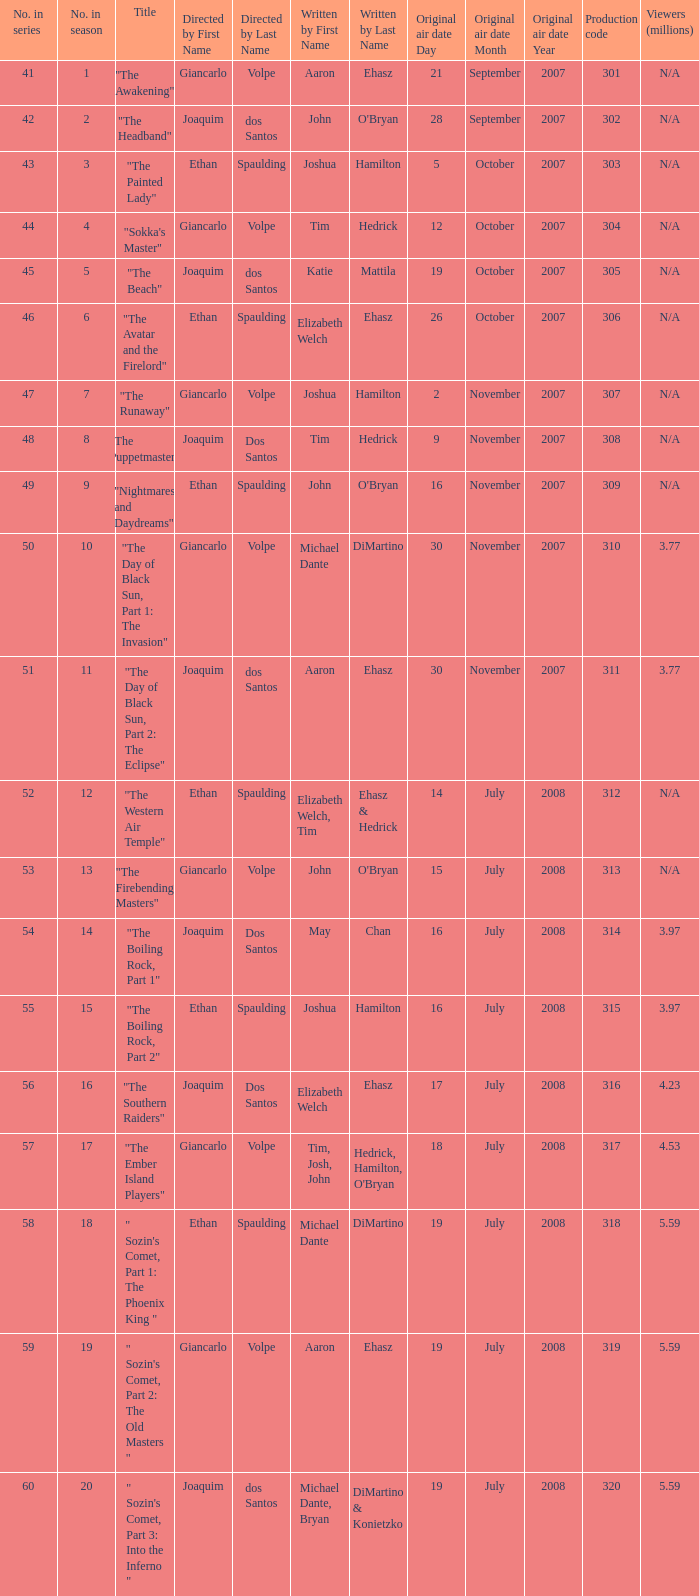Could you help me parse every detail presented in this table? {'header': ['No. in series', 'No. in season', 'Title', 'Directed by First Name', 'Directed by Last Name', 'Written by First Name', 'Written by Last Name', 'Original air date Day', 'Original air date Month', 'Original air date Year', 'Production code', 'Viewers (millions)'], 'rows': [['41', '1', '"The Awakening"', 'Giancarlo', 'Volpe', 'Aaron', 'Ehasz', '21', 'September', '2007', '301', 'N/A'], ['42', '2', '"The Headband"', 'Joaquim', 'dos Santos', 'John', "O'Bryan", '28', 'September', '2007', '302', 'N/A'], ['43', '3', '"The Painted Lady"', 'Ethan', 'Spaulding', 'Joshua', 'Hamilton', '5', 'October', '2007', '303', 'N/A'], ['44', '4', '"Sokka\'s Master"', 'Giancarlo', 'Volpe', 'Tim', 'Hedrick', '12', 'October', '2007', '304', 'N/A'], ['45', '5', '"The Beach"', 'Joaquim', 'dos Santos', 'Katie', 'Mattila', '19', 'October', '2007', '305', 'N/A'], ['46', '6', '"The Avatar and the Firelord"', 'Ethan', 'Spaulding', 'Elizabeth Welch', 'Ehasz', '26', 'October', '2007', '306', 'N/A'], ['47', '7', '"The Runaway"', 'Giancarlo', 'Volpe', 'Joshua', 'Hamilton', '2', 'November', '2007', '307', 'N/A'], ['48', '8', '"The Puppetmaster"', 'Joaquim', 'Dos Santos', 'Tim', 'Hedrick', '9', 'November', '2007', '308', 'N/A'], ['49', '9', '"Nightmares and Daydreams"', 'Ethan', 'Spaulding', 'John', "O'Bryan", '16', 'November', '2007', '309', 'N/A'], ['50', '10', '"The Day of Black Sun, Part 1: The Invasion"', 'Giancarlo', 'Volpe', 'Michael Dante', 'DiMartino', '30', 'November', '2007', '310', '3.77'], ['51', '11', '"The Day of Black Sun, Part 2: The Eclipse"', 'Joaquim', 'dos Santos', 'Aaron', 'Ehasz', '30', 'November', '2007', '311', '3.77'], ['52', '12', '"The Western Air Temple"', 'Ethan', 'Spaulding', 'Elizabeth Welch, Tim', 'Ehasz & Hedrick', '14', 'July', '2008', '312', 'N/A'], ['53', '13', '"The Firebending Masters"', 'Giancarlo', 'Volpe', 'John', "O'Bryan", '15', 'July', '2008', '313', 'N/A'], ['54', '14', '"The Boiling Rock, Part 1"', 'Joaquim', 'Dos Santos', 'May', 'Chan', '16', 'July', '2008', '314', '3.97'], ['55', '15', '"The Boiling Rock, Part 2"', 'Ethan', 'Spaulding', 'Joshua', 'Hamilton', '16', 'July', '2008', '315', '3.97'], ['56', '16', '"The Southern Raiders"', 'Joaquim', 'Dos Santos', 'Elizabeth Welch', 'Ehasz', '17', 'July', '2008', '316', '4.23'], ['57', '17', '"The Ember Island Players"', 'Giancarlo', 'Volpe', 'Tim, Josh, John', "Hedrick, Hamilton, O'Bryan", '18', 'July', '2008', '317', '4.53'], ['58', '18', '" Sozin\'s Comet, Part 1: The Phoenix King "', 'Ethan', 'Spaulding', 'Michael Dante', 'DiMartino', '19', 'July', '2008', '318', '5.59'], ['59', '19', '" Sozin\'s Comet, Part 2: The Old Masters "', 'Giancarlo', 'Volpe', 'Aaron', 'Ehasz', '19', 'July', '2008', '319', '5.59'], ['60', '20', '" Sozin\'s Comet, Part 3: Into the Inferno "', 'Joaquim', 'dos Santos', 'Michael Dante, Bryan', 'DiMartino & Konietzko', '19', 'July', '2008', '320', '5.59']]} What season has an episode written by john o'bryan and directed by ethan spaulding? 9.0. 